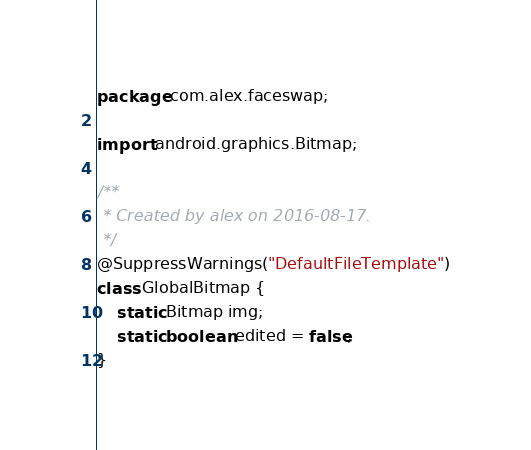Convert code to text. <code><loc_0><loc_0><loc_500><loc_500><_Java_>package com.alex.faceswap;

import android.graphics.Bitmap;

/**
 * Created by alex on 2016-08-17.
 */
@SuppressWarnings("DefaultFileTemplate")
class GlobalBitmap {
    static Bitmap img;
    static boolean edited = false;
}
</code> 